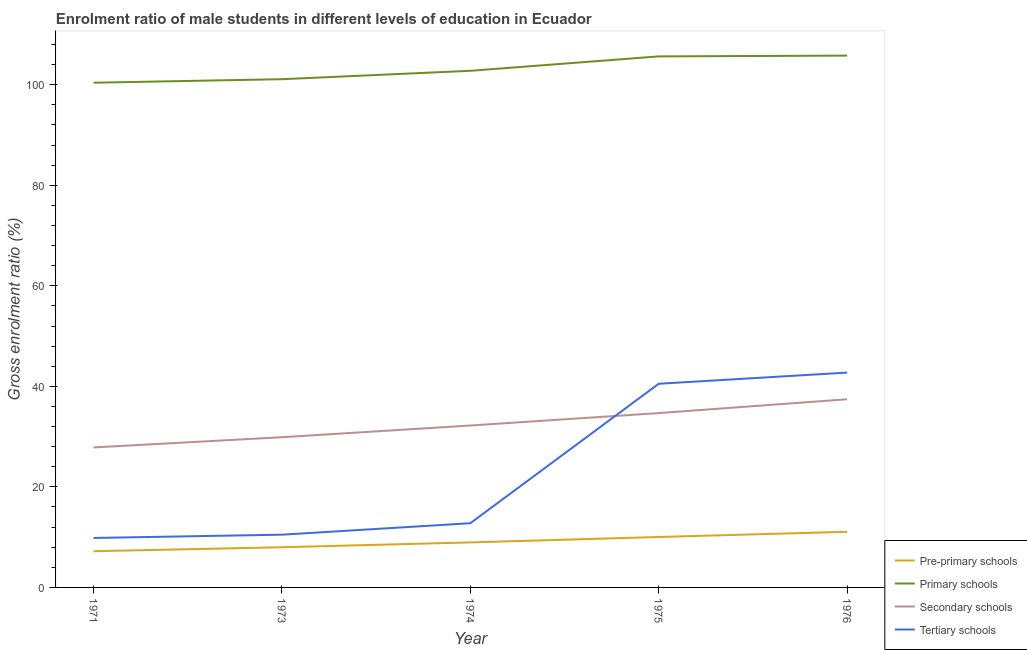What is the gross enrolment ratio(female) in secondary schools in 1971?
Keep it short and to the point. 27.85. Across all years, what is the maximum gross enrolment ratio(female) in secondary schools?
Keep it short and to the point. 37.43. Across all years, what is the minimum gross enrolment ratio(female) in pre-primary schools?
Give a very brief answer. 7.2. In which year was the gross enrolment ratio(female) in primary schools maximum?
Offer a terse response. 1976. What is the total gross enrolment ratio(female) in tertiary schools in the graph?
Ensure brevity in your answer.  116.36. What is the difference between the gross enrolment ratio(female) in primary schools in 1975 and that in 1976?
Provide a succinct answer. -0.15. What is the difference between the gross enrolment ratio(female) in primary schools in 1974 and the gross enrolment ratio(female) in tertiary schools in 1976?
Ensure brevity in your answer.  60.04. What is the average gross enrolment ratio(female) in pre-primary schools per year?
Your answer should be very brief. 9.05. In the year 1973, what is the difference between the gross enrolment ratio(female) in secondary schools and gross enrolment ratio(female) in tertiary schools?
Your response must be concise. 19.39. In how many years, is the gross enrolment ratio(female) in pre-primary schools greater than 68 %?
Provide a succinct answer. 0. What is the ratio of the gross enrolment ratio(female) in primary schools in 1975 to that in 1976?
Your answer should be compact. 1. Is the gross enrolment ratio(female) in pre-primary schools in 1973 less than that in 1974?
Your answer should be very brief. Yes. Is the difference between the gross enrolment ratio(female) in secondary schools in 1973 and 1976 greater than the difference between the gross enrolment ratio(female) in primary schools in 1973 and 1976?
Offer a terse response. No. What is the difference between the highest and the second highest gross enrolment ratio(female) in pre-primary schools?
Keep it short and to the point. 1.04. What is the difference between the highest and the lowest gross enrolment ratio(female) in pre-primary schools?
Your response must be concise. 3.87. In how many years, is the gross enrolment ratio(female) in tertiary schools greater than the average gross enrolment ratio(female) in tertiary schools taken over all years?
Give a very brief answer. 2. Is it the case that in every year, the sum of the gross enrolment ratio(female) in tertiary schools and gross enrolment ratio(female) in pre-primary schools is greater than the sum of gross enrolment ratio(female) in secondary schools and gross enrolment ratio(female) in primary schools?
Keep it short and to the point. No. Is the gross enrolment ratio(female) in secondary schools strictly greater than the gross enrolment ratio(female) in tertiary schools over the years?
Keep it short and to the point. No. Is the gross enrolment ratio(female) in tertiary schools strictly less than the gross enrolment ratio(female) in pre-primary schools over the years?
Your answer should be very brief. No. How many lines are there?
Offer a terse response. 4. What is the difference between two consecutive major ticks on the Y-axis?
Offer a very short reply. 20. Where does the legend appear in the graph?
Your answer should be very brief. Bottom right. How are the legend labels stacked?
Give a very brief answer. Vertical. What is the title of the graph?
Offer a terse response. Enrolment ratio of male students in different levels of education in Ecuador. Does "Gender equality" appear as one of the legend labels in the graph?
Your answer should be very brief. No. What is the label or title of the X-axis?
Provide a short and direct response. Year. What is the label or title of the Y-axis?
Keep it short and to the point. Gross enrolment ratio (%). What is the Gross enrolment ratio (%) in Pre-primary schools in 1971?
Offer a terse response. 7.2. What is the Gross enrolment ratio (%) in Primary schools in 1971?
Keep it short and to the point. 100.41. What is the Gross enrolment ratio (%) in Secondary schools in 1971?
Make the answer very short. 27.85. What is the Gross enrolment ratio (%) of Tertiary schools in 1971?
Provide a succinct answer. 9.84. What is the Gross enrolment ratio (%) of Pre-primary schools in 1973?
Offer a very short reply. 7.99. What is the Gross enrolment ratio (%) in Primary schools in 1973?
Make the answer very short. 101.11. What is the Gross enrolment ratio (%) of Secondary schools in 1973?
Your answer should be very brief. 29.88. What is the Gross enrolment ratio (%) of Tertiary schools in 1973?
Your answer should be very brief. 10.49. What is the Gross enrolment ratio (%) in Pre-primary schools in 1974?
Your response must be concise. 8.96. What is the Gross enrolment ratio (%) of Primary schools in 1974?
Keep it short and to the point. 102.78. What is the Gross enrolment ratio (%) in Secondary schools in 1974?
Ensure brevity in your answer.  32.21. What is the Gross enrolment ratio (%) of Tertiary schools in 1974?
Your response must be concise. 12.77. What is the Gross enrolment ratio (%) of Pre-primary schools in 1975?
Offer a terse response. 10.03. What is the Gross enrolment ratio (%) of Primary schools in 1975?
Offer a very short reply. 105.65. What is the Gross enrolment ratio (%) of Secondary schools in 1975?
Ensure brevity in your answer.  34.68. What is the Gross enrolment ratio (%) in Tertiary schools in 1975?
Your answer should be very brief. 40.52. What is the Gross enrolment ratio (%) in Pre-primary schools in 1976?
Offer a very short reply. 11.07. What is the Gross enrolment ratio (%) of Primary schools in 1976?
Make the answer very short. 105.8. What is the Gross enrolment ratio (%) in Secondary schools in 1976?
Give a very brief answer. 37.43. What is the Gross enrolment ratio (%) in Tertiary schools in 1976?
Your response must be concise. 42.74. Across all years, what is the maximum Gross enrolment ratio (%) in Pre-primary schools?
Offer a terse response. 11.07. Across all years, what is the maximum Gross enrolment ratio (%) of Primary schools?
Your response must be concise. 105.8. Across all years, what is the maximum Gross enrolment ratio (%) of Secondary schools?
Make the answer very short. 37.43. Across all years, what is the maximum Gross enrolment ratio (%) of Tertiary schools?
Offer a terse response. 42.74. Across all years, what is the minimum Gross enrolment ratio (%) of Pre-primary schools?
Give a very brief answer. 7.2. Across all years, what is the minimum Gross enrolment ratio (%) of Primary schools?
Give a very brief answer. 100.41. Across all years, what is the minimum Gross enrolment ratio (%) of Secondary schools?
Provide a succinct answer. 27.85. Across all years, what is the minimum Gross enrolment ratio (%) of Tertiary schools?
Your answer should be compact. 9.84. What is the total Gross enrolment ratio (%) of Pre-primary schools in the graph?
Your answer should be compact. 45.25. What is the total Gross enrolment ratio (%) of Primary schools in the graph?
Your answer should be compact. 515.74. What is the total Gross enrolment ratio (%) of Secondary schools in the graph?
Your response must be concise. 162.06. What is the total Gross enrolment ratio (%) in Tertiary schools in the graph?
Your response must be concise. 116.36. What is the difference between the Gross enrolment ratio (%) of Pre-primary schools in 1971 and that in 1973?
Provide a succinct answer. -0.79. What is the difference between the Gross enrolment ratio (%) of Primary schools in 1971 and that in 1973?
Provide a succinct answer. -0.7. What is the difference between the Gross enrolment ratio (%) in Secondary schools in 1971 and that in 1973?
Offer a terse response. -2.03. What is the difference between the Gross enrolment ratio (%) in Tertiary schools in 1971 and that in 1973?
Provide a succinct answer. -0.65. What is the difference between the Gross enrolment ratio (%) of Pre-primary schools in 1971 and that in 1974?
Your answer should be compact. -1.75. What is the difference between the Gross enrolment ratio (%) in Primary schools in 1971 and that in 1974?
Ensure brevity in your answer.  -2.37. What is the difference between the Gross enrolment ratio (%) of Secondary schools in 1971 and that in 1974?
Make the answer very short. -4.36. What is the difference between the Gross enrolment ratio (%) in Tertiary schools in 1971 and that in 1974?
Make the answer very short. -2.94. What is the difference between the Gross enrolment ratio (%) in Pre-primary schools in 1971 and that in 1975?
Give a very brief answer. -2.83. What is the difference between the Gross enrolment ratio (%) of Primary schools in 1971 and that in 1975?
Your response must be concise. -5.24. What is the difference between the Gross enrolment ratio (%) of Secondary schools in 1971 and that in 1975?
Your response must be concise. -6.83. What is the difference between the Gross enrolment ratio (%) in Tertiary schools in 1971 and that in 1975?
Give a very brief answer. -30.68. What is the difference between the Gross enrolment ratio (%) of Pre-primary schools in 1971 and that in 1976?
Offer a terse response. -3.87. What is the difference between the Gross enrolment ratio (%) in Primary schools in 1971 and that in 1976?
Give a very brief answer. -5.39. What is the difference between the Gross enrolment ratio (%) in Secondary schools in 1971 and that in 1976?
Offer a terse response. -9.58. What is the difference between the Gross enrolment ratio (%) of Tertiary schools in 1971 and that in 1976?
Offer a terse response. -32.9. What is the difference between the Gross enrolment ratio (%) in Pre-primary schools in 1973 and that in 1974?
Make the answer very short. -0.96. What is the difference between the Gross enrolment ratio (%) of Primary schools in 1973 and that in 1974?
Ensure brevity in your answer.  -1.67. What is the difference between the Gross enrolment ratio (%) in Secondary schools in 1973 and that in 1974?
Your answer should be compact. -2.33. What is the difference between the Gross enrolment ratio (%) of Tertiary schools in 1973 and that in 1974?
Offer a very short reply. -2.28. What is the difference between the Gross enrolment ratio (%) in Pre-primary schools in 1973 and that in 1975?
Offer a terse response. -2.04. What is the difference between the Gross enrolment ratio (%) in Primary schools in 1973 and that in 1975?
Your answer should be compact. -4.54. What is the difference between the Gross enrolment ratio (%) of Secondary schools in 1973 and that in 1975?
Make the answer very short. -4.8. What is the difference between the Gross enrolment ratio (%) in Tertiary schools in 1973 and that in 1975?
Provide a short and direct response. -30.03. What is the difference between the Gross enrolment ratio (%) of Pre-primary schools in 1973 and that in 1976?
Offer a very short reply. -3.07. What is the difference between the Gross enrolment ratio (%) of Primary schools in 1973 and that in 1976?
Keep it short and to the point. -4.69. What is the difference between the Gross enrolment ratio (%) of Secondary schools in 1973 and that in 1976?
Offer a very short reply. -7.55. What is the difference between the Gross enrolment ratio (%) of Tertiary schools in 1973 and that in 1976?
Keep it short and to the point. -32.24. What is the difference between the Gross enrolment ratio (%) in Pre-primary schools in 1974 and that in 1975?
Keep it short and to the point. -1.08. What is the difference between the Gross enrolment ratio (%) in Primary schools in 1974 and that in 1975?
Keep it short and to the point. -2.87. What is the difference between the Gross enrolment ratio (%) of Secondary schools in 1974 and that in 1975?
Ensure brevity in your answer.  -2.47. What is the difference between the Gross enrolment ratio (%) of Tertiary schools in 1974 and that in 1975?
Provide a short and direct response. -27.75. What is the difference between the Gross enrolment ratio (%) in Pre-primary schools in 1974 and that in 1976?
Your answer should be compact. -2.11. What is the difference between the Gross enrolment ratio (%) in Primary schools in 1974 and that in 1976?
Provide a succinct answer. -3.02. What is the difference between the Gross enrolment ratio (%) of Secondary schools in 1974 and that in 1976?
Offer a very short reply. -5.22. What is the difference between the Gross enrolment ratio (%) of Tertiary schools in 1974 and that in 1976?
Your answer should be very brief. -29.96. What is the difference between the Gross enrolment ratio (%) of Pre-primary schools in 1975 and that in 1976?
Your answer should be very brief. -1.04. What is the difference between the Gross enrolment ratio (%) of Primary schools in 1975 and that in 1976?
Offer a terse response. -0.15. What is the difference between the Gross enrolment ratio (%) in Secondary schools in 1975 and that in 1976?
Provide a short and direct response. -2.75. What is the difference between the Gross enrolment ratio (%) of Tertiary schools in 1975 and that in 1976?
Provide a succinct answer. -2.22. What is the difference between the Gross enrolment ratio (%) in Pre-primary schools in 1971 and the Gross enrolment ratio (%) in Primary schools in 1973?
Provide a short and direct response. -93.9. What is the difference between the Gross enrolment ratio (%) in Pre-primary schools in 1971 and the Gross enrolment ratio (%) in Secondary schools in 1973?
Your answer should be compact. -22.68. What is the difference between the Gross enrolment ratio (%) in Pre-primary schools in 1971 and the Gross enrolment ratio (%) in Tertiary schools in 1973?
Give a very brief answer. -3.29. What is the difference between the Gross enrolment ratio (%) of Primary schools in 1971 and the Gross enrolment ratio (%) of Secondary schools in 1973?
Offer a very short reply. 70.53. What is the difference between the Gross enrolment ratio (%) of Primary schools in 1971 and the Gross enrolment ratio (%) of Tertiary schools in 1973?
Make the answer very short. 89.91. What is the difference between the Gross enrolment ratio (%) in Secondary schools in 1971 and the Gross enrolment ratio (%) in Tertiary schools in 1973?
Give a very brief answer. 17.36. What is the difference between the Gross enrolment ratio (%) of Pre-primary schools in 1971 and the Gross enrolment ratio (%) of Primary schools in 1974?
Your answer should be compact. -95.57. What is the difference between the Gross enrolment ratio (%) of Pre-primary schools in 1971 and the Gross enrolment ratio (%) of Secondary schools in 1974?
Provide a short and direct response. -25.01. What is the difference between the Gross enrolment ratio (%) in Pre-primary schools in 1971 and the Gross enrolment ratio (%) in Tertiary schools in 1974?
Provide a succinct answer. -5.57. What is the difference between the Gross enrolment ratio (%) in Primary schools in 1971 and the Gross enrolment ratio (%) in Secondary schools in 1974?
Provide a succinct answer. 68.2. What is the difference between the Gross enrolment ratio (%) of Primary schools in 1971 and the Gross enrolment ratio (%) of Tertiary schools in 1974?
Provide a short and direct response. 87.63. What is the difference between the Gross enrolment ratio (%) in Secondary schools in 1971 and the Gross enrolment ratio (%) in Tertiary schools in 1974?
Ensure brevity in your answer.  15.08. What is the difference between the Gross enrolment ratio (%) in Pre-primary schools in 1971 and the Gross enrolment ratio (%) in Primary schools in 1975?
Make the answer very short. -98.44. What is the difference between the Gross enrolment ratio (%) of Pre-primary schools in 1971 and the Gross enrolment ratio (%) of Secondary schools in 1975?
Your answer should be very brief. -27.48. What is the difference between the Gross enrolment ratio (%) in Pre-primary schools in 1971 and the Gross enrolment ratio (%) in Tertiary schools in 1975?
Your answer should be very brief. -33.32. What is the difference between the Gross enrolment ratio (%) in Primary schools in 1971 and the Gross enrolment ratio (%) in Secondary schools in 1975?
Offer a terse response. 65.73. What is the difference between the Gross enrolment ratio (%) of Primary schools in 1971 and the Gross enrolment ratio (%) of Tertiary schools in 1975?
Provide a short and direct response. 59.89. What is the difference between the Gross enrolment ratio (%) in Secondary schools in 1971 and the Gross enrolment ratio (%) in Tertiary schools in 1975?
Keep it short and to the point. -12.67. What is the difference between the Gross enrolment ratio (%) of Pre-primary schools in 1971 and the Gross enrolment ratio (%) of Primary schools in 1976?
Provide a succinct answer. -98.6. What is the difference between the Gross enrolment ratio (%) in Pre-primary schools in 1971 and the Gross enrolment ratio (%) in Secondary schools in 1976?
Make the answer very short. -30.23. What is the difference between the Gross enrolment ratio (%) of Pre-primary schools in 1971 and the Gross enrolment ratio (%) of Tertiary schools in 1976?
Offer a terse response. -35.53. What is the difference between the Gross enrolment ratio (%) in Primary schools in 1971 and the Gross enrolment ratio (%) in Secondary schools in 1976?
Keep it short and to the point. 62.97. What is the difference between the Gross enrolment ratio (%) of Primary schools in 1971 and the Gross enrolment ratio (%) of Tertiary schools in 1976?
Keep it short and to the point. 57.67. What is the difference between the Gross enrolment ratio (%) in Secondary schools in 1971 and the Gross enrolment ratio (%) in Tertiary schools in 1976?
Offer a terse response. -14.89. What is the difference between the Gross enrolment ratio (%) of Pre-primary schools in 1973 and the Gross enrolment ratio (%) of Primary schools in 1974?
Provide a succinct answer. -94.78. What is the difference between the Gross enrolment ratio (%) of Pre-primary schools in 1973 and the Gross enrolment ratio (%) of Secondary schools in 1974?
Your answer should be compact. -24.21. What is the difference between the Gross enrolment ratio (%) in Pre-primary schools in 1973 and the Gross enrolment ratio (%) in Tertiary schools in 1974?
Your response must be concise. -4.78. What is the difference between the Gross enrolment ratio (%) in Primary schools in 1973 and the Gross enrolment ratio (%) in Secondary schools in 1974?
Provide a succinct answer. 68.9. What is the difference between the Gross enrolment ratio (%) of Primary schools in 1973 and the Gross enrolment ratio (%) of Tertiary schools in 1974?
Offer a very short reply. 88.33. What is the difference between the Gross enrolment ratio (%) in Secondary schools in 1973 and the Gross enrolment ratio (%) in Tertiary schools in 1974?
Provide a succinct answer. 17.11. What is the difference between the Gross enrolment ratio (%) of Pre-primary schools in 1973 and the Gross enrolment ratio (%) of Primary schools in 1975?
Your answer should be compact. -97.65. What is the difference between the Gross enrolment ratio (%) of Pre-primary schools in 1973 and the Gross enrolment ratio (%) of Secondary schools in 1975?
Keep it short and to the point. -26.69. What is the difference between the Gross enrolment ratio (%) in Pre-primary schools in 1973 and the Gross enrolment ratio (%) in Tertiary schools in 1975?
Give a very brief answer. -32.53. What is the difference between the Gross enrolment ratio (%) of Primary schools in 1973 and the Gross enrolment ratio (%) of Secondary schools in 1975?
Offer a very short reply. 66.43. What is the difference between the Gross enrolment ratio (%) in Primary schools in 1973 and the Gross enrolment ratio (%) in Tertiary schools in 1975?
Give a very brief answer. 60.59. What is the difference between the Gross enrolment ratio (%) of Secondary schools in 1973 and the Gross enrolment ratio (%) of Tertiary schools in 1975?
Provide a short and direct response. -10.64. What is the difference between the Gross enrolment ratio (%) of Pre-primary schools in 1973 and the Gross enrolment ratio (%) of Primary schools in 1976?
Offer a terse response. -97.81. What is the difference between the Gross enrolment ratio (%) in Pre-primary schools in 1973 and the Gross enrolment ratio (%) in Secondary schools in 1976?
Your response must be concise. -29.44. What is the difference between the Gross enrolment ratio (%) in Pre-primary schools in 1973 and the Gross enrolment ratio (%) in Tertiary schools in 1976?
Ensure brevity in your answer.  -34.74. What is the difference between the Gross enrolment ratio (%) in Primary schools in 1973 and the Gross enrolment ratio (%) in Secondary schools in 1976?
Keep it short and to the point. 63.67. What is the difference between the Gross enrolment ratio (%) of Primary schools in 1973 and the Gross enrolment ratio (%) of Tertiary schools in 1976?
Offer a very short reply. 58.37. What is the difference between the Gross enrolment ratio (%) of Secondary schools in 1973 and the Gross enrolment ratio (%) of Tertiary schools in 1976?
Keep it short and to the point. -12.86. What is the difference between the Gross enrolment ratio (%) in Pre-primary schools in 1974 and the Gross enrolment ratio (%) in Primary schools in 1975?
Your response must be concise. -96.69. What is the difference between the Gross enrolment ratio (%) of Pre-primary schools in 1974 and the Gross enrolment ratio (%) of Secondary schools in 1975?
Offer a very short reply. -25.73. What is the difference between the Gross enrolment ratio (%) in Pre-primary schools in 1974 and the Gross enrolment ratio (%) in Tertiary schools in 1975?
Offer a terse response. -31.56. What is the difference between the Gross enrolment ratio (%) in Primary schools in 1974 and the Gross enrolment ratio (%) in Secondary schools in 1975?
Keep it short and to the point. 68.09. What is the difference between the Gross enrolment ratio (%) of Primary schools in 1974 and the Gross enrolment ratio (%) of Tertiary schools in 1975?
Ensure brevity in your answer.  62.26. What is the difference between the Gross enrolment ratio (%) of Secondary schools in 1974 and the Gross enrolment ratio (%) of Tertiary schools in 1975?
Make the answer very short. -8.31. What is the difference between the Gross enrolment ratio (%) in Pre-primary schools in 1974 and the Gross enrolment ratio (%) in Primary schools in 1976?
Offer a terse response. -96.84. What is the difference between the Gross enrolment ratio (%) of Pre-primary schools in 1974 and the Gross enrolment ratio (%) of Secondary schools in 1976?
Give a very brief answer. -28.48. What is the difference between the Gross enrolment ratio (%) of Pre-primary schools in 1974 and the Gross enrolment ratio (%) of Tertiary schools in 1976?
Keep it short and to the point. -33.78. What is the difference between the Gross enrolment ratio (%) of Primary schools in 1974 and the Gross enrolment ratio (%) of Secondary schools in 1976?
Give a very brief answer. 65.34. What is the difference between the Gross enrolment ratio (%) in Primary schools in 1974 and the Gross enrolment ratio (%) in Tertiary schools in 1976?
Provide a short and direct response. 60.04. What is the difference between the Gross enrolment ratio (%) in Secondary schools in 1974 and the Gross enrolment ratio (%) in Tertiary schools in 1976?
Keep it short and to the point. -10.53. What is the difference between the Gross enrolment ratio (%) in Pre-primary schools in 1975 and the Gross enrolment ratio (%) in Primary schools in 1976?
Keep it short and to the point. -95.77. What is the difference between the Gross enrolment ratio (%) of Pre-primary schools in 1975 and the Gross enrolment ratio (%) of Secondary schools in 1976?
Provide a succinct answer. -27.4. What is the difference between the Gross enrolment ratio (%) of Pre-primary schools in 1975 and the Gross enrolment ratio (%) of Tertiary schools in 1976?
Ensure brevity in your answer.  -32.71. What is the difference between the Gross enrolment ratio (%) of Primary schools in 1975 and the Gross enrolment ratio (%) of Secondary schools in 1976?
Provide a succinct answer. 68.21. What is the difference between the Gross enrolment ratio (%) of Primary schools in 1975 and the Gross enrolment ratio (%) of Tertiary schools in 1976?
Your response must be concise. 62.91. What is the difference between the Gross enrolment ratio (%) of Secondary schools in 1975 and the Gross enrolment ratio (%) of Tertiary schools in 1976?
Make the answer very short. -8.06. What is the average Gross enrolment ratio (%) of Pre-primary schools per year?
Your answer should be very brief. 9.05. What is the average Gross enrolment ratio (%) of Primary schools per year?
Your response must be concise. 103.15. What is the average Gross enrolment ratio (%) of Secondary schools per year?
Offer a terse response. 32.41. What is the average Gross enrolment ratio (%) in Tertiary schools per year?
Keep it short and to the point. 23.27. In the year 1971, what is the difference between the Gross enrolment ratio (%) of Pre-primary schools and Gross enrolment ratio (%) of Primary schools?
Make the answer very short. -93.2. In the year 1971, what is the difference between the Gross enrolment ratio (%) of Pre-primary schools and Gross enrolment ratio (%) of Secondary schools?
Provide a succinct answer. -20.65. In the year 1971, what is the difference between the Gross enrolment ratio (%) in Pre-primary schools and Gross enrolment ratio (%) in Tertiary schools?
Offer a very short reply. -2.64. In the year 1971, what is the difference between the Gross enrolment ratio (%) in Primary schools and Gross enrolment ratio (%) in Secondary schools?
Provide a short and direct response. 72.56. In the year 1971, what is the difference between the Gross enrolment ratio (%) of Primary schools and Gross enrolment ratio (%) of Tertiary schools?
Provide a succinct answer. 90.57. In the year 1971, what is the difference between the Gross enrolment ratio (%) in Secondary schools and Gross enrolment ratio (%) in Tertiary schools?
Your answer should be very brief. 18.01. In the year 1973, what is the difference between the Gross enrolment ratio (%) in Pre-primary schools and Gross enrolment ratio (%) in Primary schools?
Your answer should be very brief. -93.11. In the year 1973, what is the difference between the Gross enrolment ratio (%) in Pre-primary schools and Gross enrolment ratio (%) in Secondary schools?
Offer a very short reply. -21.89. In the year 1973, what is the difference between the Gross enrolment ratio (%) in Pre-primary schools and Gross enrolment ratio (%) in Tertiary schools?
Provide a succinct answer. -2.5. In the year 1973, what is the difference between the Gross enrolment ratio (%) in Primary schools and Gross enrolment ratio (%) in Secondary schools?
Your answer should be compact. 71.22. In the year 1973, what is the difference between the Gross enrolment ratio (%) of Primary schools and Gross enrolment ratio (%) of Tertiary schools?
Offer a very short reply. 90.61. In the year 1973, what is the difference between the Gross enrolment ratio (%) in Secondary schools and Gross enrolment ratio (%) in Tertiary schools?
Your answer should be very brief. 19.39. In the year 1974, what is the difference between the Gross enrolment ratio (%) in Pre-primary schools and Gross enrolment ratio (%) in Primary schools?
Give a very brief answer. -93.82. In the year 1974, what is the difference between the Gross enrolment ratio (%) of Pre-primary schools and Gross enrolment ratio (%) of Secondary schools?
Make the answer very short. -23.25. In the year 1974, what is the difference between the Gross enrolment ratio (%) in Pre-primary schools and Gross enrolment ratio (%) in Tertiary schools?
Ensure brevity in your answer.  -3.82. In the year 1974, what is the difference between the Gross enrolment ratio (%) of Primary schools and Gross enrolment ratio (%) of Secondary schools?
Your answer should be very brief. 70.57. In the year 1974, what is the difference between the Gross enrolment ratio (%) of Primary schools and Gross enrolment ratio (%) of Tertiary schools?
Your response must be concise. 90. In the year 1974, what is the difference between the Gross enrolment ratio (%) of Secondary schools and Gross enrolment ratio (%) of Tertiary schools?
Keep it short and to the point. 19.43. In the year 1975, what is the difference between the Gross enrolment ratio (%) in Pre-primary schools and Gross enrolment ratio (%) in Primary schools?
Provide a short and direct response. -95.61. In the year 1975, what is the difference between the Gross enrolment ratio (%) of Pre-primary schools and Gross enrolment ratio (%) of Secondary schools?
Your answer should be very brief. -24.65. In the year 1975, what is the difference between the Gross enrolment ratio (%) in Pre-primary schools and Gross enrolment ratio (%) in Tertiary schools?
Make the answer very short. -30.49. In the year 1975, what is the difference between the Gross enrolment ratio (%) in Primary schools and Gross enrolment ratio (%) in Secondary schools?
Make the answer very short. 70.96. In the year 1975, what is the difference between the Gross enrolment ratio (%) of Primary schools and Gross enrolment ratio (%) of Tertiary schools?
Keep it short and to the point. 65.13. In the year 1975, what is the difference between the Gross enrolment ratio (%) in Secondary schools and Gross enrolment ratio (%) in Tertiary schools?
Your answer should be compact. -5.84. In the year 1976, what is the difference between the Gross enrolment ratio (%) of Pre-primary schools and Gross enrolment ratio (%) of Primary schools?
Ensure brevity in your answer.  -94.73. In the year 1976, what is the difference between the Gross enrolment ratio (%) of Pre-primary schools and Gross enrolment ratio (%) of Secondary schools?
Offer a terse response. -26.36. In the year 1976, what is the difference between the Gross enrolment ratio (%) of Pre-primary schools and Gross enrolment ratio (%) of Tertiary schools?
Your response must be concise. -31.67. In the year 1976, what is the difference between the Gross enrolment ratio (%) in Primary schools and Gross enrolment ratio (%) in Secondary schools?
Provide a short and direct response. 68.37. In the year 1976, what is the difference between the Gross enrolment ratio (%) of Primary schools and Gross enrolment ratio (%) of Tertiary schools?
Make the answer very short. 63.06. In the year 1976, what is the difference between the Gross enrolment ratio (%) in Secondary schools and Gross enrolment ratio (%) in Tertiary schools?
Make the answer very short. -5.3. What is the ratio of the Gross enrolment ratio (%) of Pre-primary schools in 1971 to that in 1973?
Ensure brevity in your answer.  0.9. What is the ratio of the Gross enrolment ratio (%) of Primary schools in 1971 to that in 1973?
Provide a succinct answer. 0.99. What is the ratio of the Gross enrolment ratio (%) of Secondary schools in 1971 to that in 1973?
Provide a short and direct response. 0.93. What is the ratio of the Gross enrolment ratio (%) in Tertiary schools in 1971 to that in 1973?
Ensure brevity in your answer.  0.94. What is the ratio of the Gross enrolment ratio (%) of Pre-primary schools in 1971 to that in 1974?
Keep it short and to the point. 0.8. What is the ratio of the Gross enrolment ratio (%) of Primary schools in 1971 to that in 1974?
Offer a terse response. 0.98. What is the ratio of the Gross enrolment ratio (%) of Secondary schools in 1971 to that in 1974?
Provide a short and direct response. 0.86. What is the ratio of the Gross enrolment ratio (%) of Tertiary schools in 1971 to that in 1974?
Give a very brief answer. 0.77. What is the ratio of the Gross enrolment ratio (%) in Pre-primary schools in 1971 to that in 1975?
Provide a succinct answer. 0.72. What is the ratio of the Gross enrolment ratio (%) of Primary schools in 1971 to that in 1975?
Your response must be concise. 0.95. What is the ratio of the Gross enrolment ratio (%) of Secondary schools in 1971 to that in 1975?
Ensure brevity in your answer.  0.8. What is the ratio of the Gross enrolment ratio (%) in Tertiary schools in 1971 to that in 1975?
Your answer should be very brief. 0.24. What is the ratio of the Gross enrolment ratio (%) of Pre-primary schools in 1971 to that in 1976?
Your response must be concise. 0.65. What is the ratio of the Gross enrolment ratio (%) in Primary schools in 1971 to that in 1976?
Your answer should be compact. 0.95. What is the ratio of the Gross enrolment ratio (%) of Secondary schools in 1971 to that in 1976?
Offer a terse response. 0.74. What is the ratio of the Gross enrolment ratio (%) of Tertiary schools in 1971 to that in 1976?
Your answer should be very brief. 0.23. What is the ratio of the Gross enrolment ratio (%) in Pre-primary schools in 1973 to that in 1974?
Make the answer very short. 0.89. What is the ratio of the Gross enrolment ratio (%) of Primary schools in 1973 to that in 1974?
Your answer should be compact. 0.98. What is the ratio of the Gross enrolment ratio (%) in Secondary schools in 1973 to that in 1974?
Give a very brief answer. 0.93. What is the ratio of the Gross enrolment ratio (%) in Tertiary schools in 1973 to that in 1974?
Offer a very short reply. 0.82. What is the ratio of the Gross enrolment ratio (%) in Pre-primary schools in 1973 to that in 1975?
Your response must be concise. 0.8. What is the ratio of the Gross enrolment ratio (%) of Primary schools in 1973 to that in 1975?
Your response must be concise. 0.96. What is the ratio of the Gross enrolment ratio (%) of Secondary schools in 1973 to that in 1975?
Your answer should be very brief. 0.86. What is the ratio of the Gross enrolment ratio (%) of Tertiary schools in 1973 to that in 1975?
Provide a short and direct response. 0.26. What is the ratio of the Gross enrolment ratio (%) of Pre-primary schools in 1973 to that in 1976?
Your answer should be compact. 0.72. What is the ratio of the Gross enrolment ratio (%) of Primary schools in 1973 to that in 1976?
Make the answer very short. 0.96. What is the ratio of the Gross enrolment ratio (%) of Secondary schools in 1973 to that in 1976?
Your answer should be very brief. 0.8. What is the ratio of the Gross enrolment ratio (%) of Tertiary schools in 1973 to that in 1976?
Make the answer very short. 0.25. What is the ratio of the Gross enrolment ratio (%) in Pre-primary schools in 1974 to that in 1975?
Provide a succinct answer. 0.89. What is the ratio of the Gross enrolment ratio (%) of Primary schools in 1974 to that in 1975?
Your answer should be very brief. 0.97. What is the ratio of the Gross enrolment ratio (%) in Secondary schools in 1974 to that in 1975?
Your answer should be compact. 0.93. What is the ratio of the Gross enrolment ratio (%) of Tertiary schools in 1974 to that in 1975?
Your response must be concise. 0.32. What is the ratio of the Gross enrolment ratio (%) of Pre-primary schools in 1974 to that in 1976?
Keep it short and to the point. 0.81. What is the ratio of the Gross enrolment ratio (%) of Primary schools in 1974 to that in 1976?
Your answer should be compact. 0.97. What is the ratio of the Gross enrolment ratio (%) of Secondary schools in 1974 to that in 1976?
Make the answer very short. 0.86. What is the ratio of the Gross enrolment ratio (%) in Tertiary schools in 1974 to that in 1976?
Your response must be concise. 0.3. What is the ratio of the Gross enrolment ratio (%) in Pre-primary schools in 1975 to that in 1976?
Your answer should be very brief. 0.91. What is the ratio of the Gross enrolment ratio (%) in Primary schools in 1975 to that in 1976?
Your answer should be very brief. 1. What is the ratio of the Gross enrolment ratio (%) of Secondary schools in 1975 to that in 1976?
Keep it short and to the point. 0.93. What is the ratio of the Gross enrolment ratio (%) of Tertiary schools in 1975 to that in 1976?
Ensure brevity in your answer.  0.95. What is the difference between the highest and the second highest Gross enrolment ratio (%) in Pre-primary schools?
Provide a succinct answer. 1.04. What is the difference between the highest and the second highest Gross enrolment ratio (%) of Primary schools?
Make the answer very short. 0.15. What is the difference between the highest and the second highest Gross enrolment ratio (%) in Secondary schools?
Provide a succinct answer. 2.75. What is the difference between the highest and the second highest Gross enrolment ratio (%) of Tertiary schools?
Keep it short and to the point. 2.22. What is the difference between the highest and the lowest Gross enrolment ratio (%) of Pre-primary schools?
Make the answer very short. 3.87. What is the difference between the highest and the lowest Gross enrolment ratio (%) of Primary schools?
Your response must be concise. 5.39. What is the difference between the highest and the lowest Gross enrolment ratio (%) of Secondary schools?
Ensure brevity in your answer.  9.58. What is the difference between the highest and the lowest Gross enrolment ratio (%) of Tertiary schools?
Your answer should be compact. 32.9. 